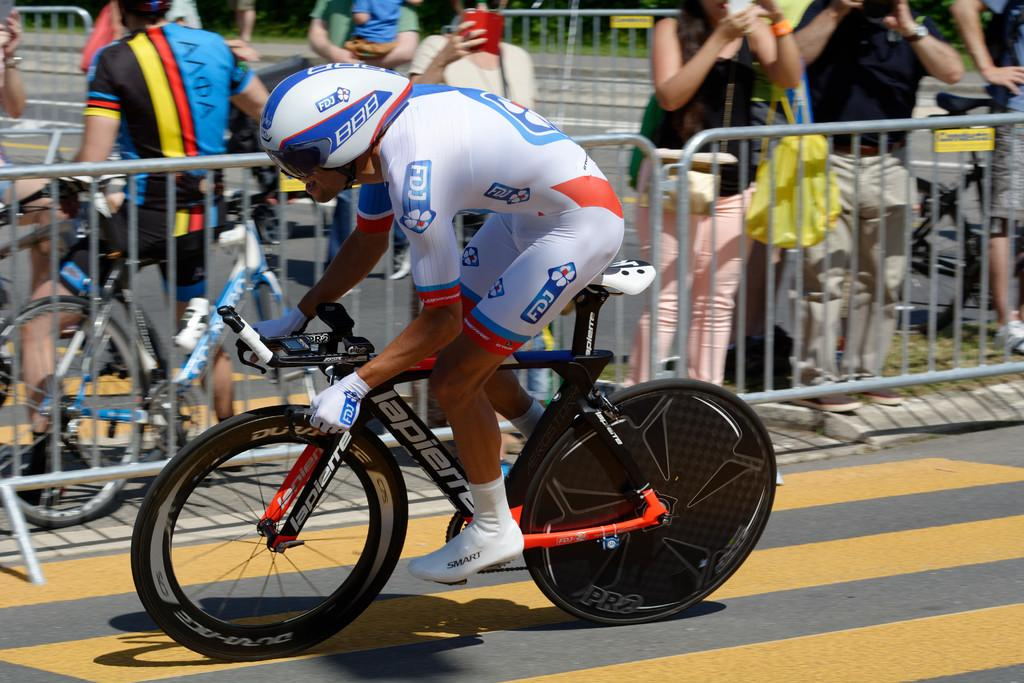How many people are in the image? There are people in the image, but the exact number is not specified. Can you describe the distribution of people in the image? The people are scattered throughout the image. What is a specific action being performed by one of the people in the image? There is a man riding a bicycle in the front of the image. What historical event is being commemorated by the doll in the image? There is no doll present in the image, so it is not possible to answer a question about a doll or any historical event related to it. 